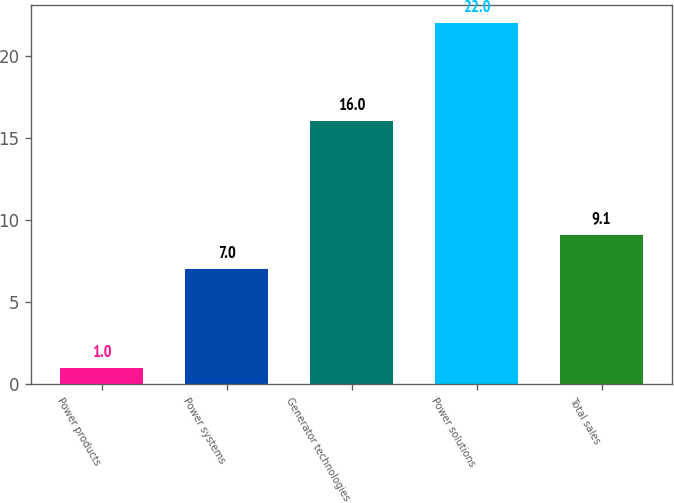Convert chart to OTSL. <chart><loc_0><loc_0><loc_500><loc_500><bar_chart><fcel>Power products<fcel>Power systems<fcel>Generator technologies<fcel>Power solutions<fcel>Total sales<nl><fcel>1<fcel>7<fcel>16<fcel>22<fcel>9.1<nl></chart> 